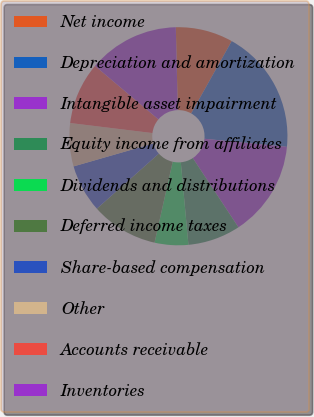<chart> <loc_0><loc_0><loc_500><loc_500><pie_chart><fcel>Net income<fcel>Depreciation and amortization<fcel>Intangible asset impairment<fcel>Equity income from affiliates<fcel>Dividends and distributions<fcel>Deferred income taxes<fcel>Share-based compensation<fcel>Other<fcel>Accounts receivable<fcel>Inventories<nl><fcel>8.51%<fcel>18.42%<fcel>14.17%<fcel>7.81%<fcel>4.98%<fcel>9.93%<fcel>7.1%<fcel>6.39%<fcel>9.22%<fcel>13.47%<nl></chart> 